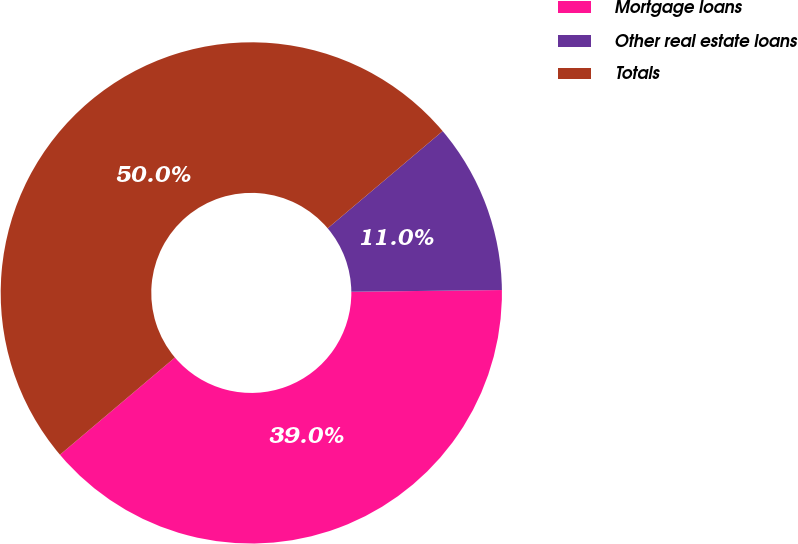Convert chart. <chart><loc_0><loc_0><loc_500><loc_500><pie_chart><fcel>Mortgage loans<fcel>Other real estate loans<fcel>Totals<nl><fcel>39.01%<fcel>10.99%<fcel>50.0%<nl></chart> 